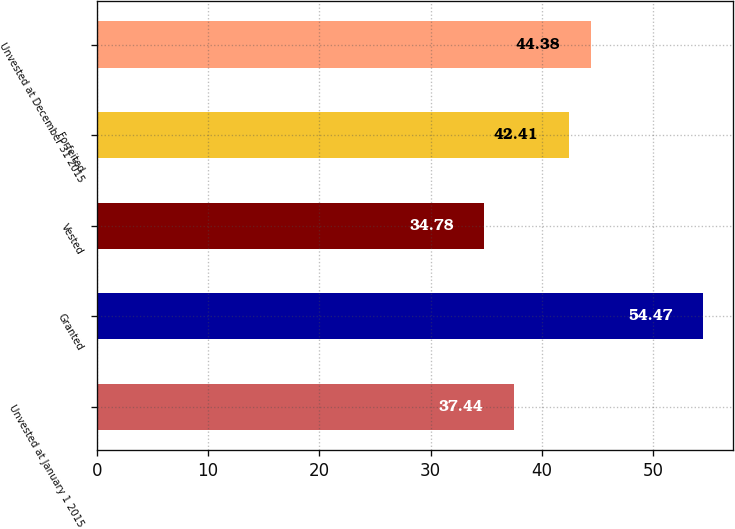<chart> <loc_0><loc_0><loc_500><loc_500><bar_chart><fcel>Unvested at January 1 2015<fcel>Granted<fcel>Vested<fcel>Forfeited<fcel>Unvested at December 31 2015<nl><fcel>37.44<fcel>54.47<fcel>34.78<fcel>42.41<fcel>44.38<nl></chart> 